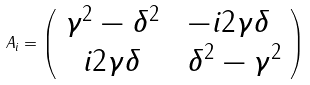Convert formula to latex. <formula><loc_0><loc_0><loc_500><loc_500>A _ { i } = \left ( \begin{array} { c l } \gamma ^ { 2 } - \delta ^ { 2 } & \ - i 2 \gamma \delta \\ i 2 \gamma \delta & \ \delta ^ { 2 } - \gamma ^ { 2 } \end{array} \right )</formula> 